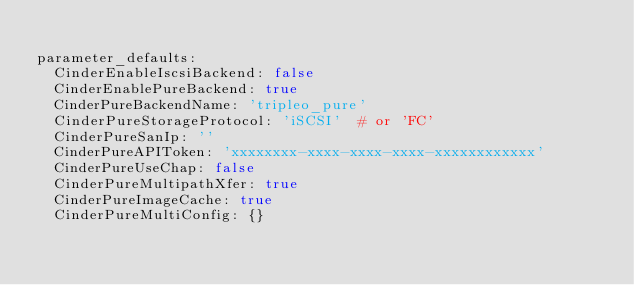<code> <loc_0><loc_0><loc_500><loc_500><_YAML_>
parameter_defaults:
  CinderEnableIscsiBackend: false
  CinderEnablePureBackend: true
  CinderPureBackendName: 'tripleo_pure'
  CinderPureStorageProtocol: 'iSCSI'  # or 'FC'
  CinderPureSanIp: ''
  CinderPureAPIToken: 'xxxxxxxx-xxxx-xxxx-xxxx-xxxxxxxxxxxx'
  CinderPureUseChap: false
  CinderPureMultipathXfer: true
  CinderPureImageCache: true
  CinderPureMultiConfig: {}
</code> 